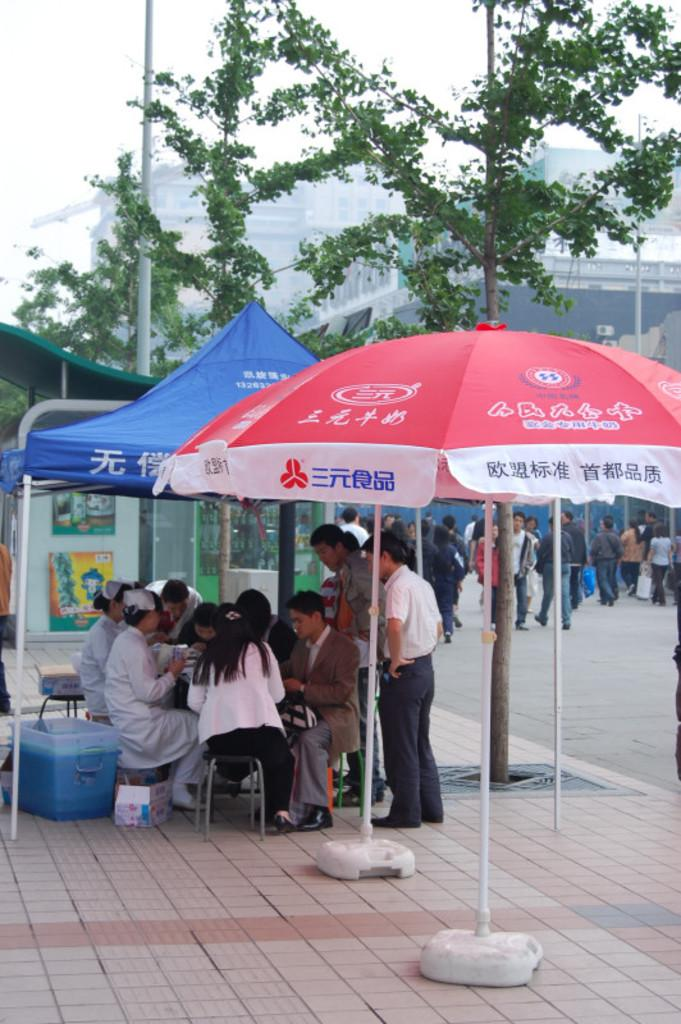What are the persons in the image doing? The persons in the image are sitting and standing under parasols. What can be seen above the persons in the image? There are poles in the background of the image. What else is visible in the background of the image? There are buildings, trees, persons on the road, and the sky visible in the background of the image. What type of industry can be seen in the image? There is no specific industry depicted in the image; it primarily features persons sitting and standing under parasols, with various background elements. 